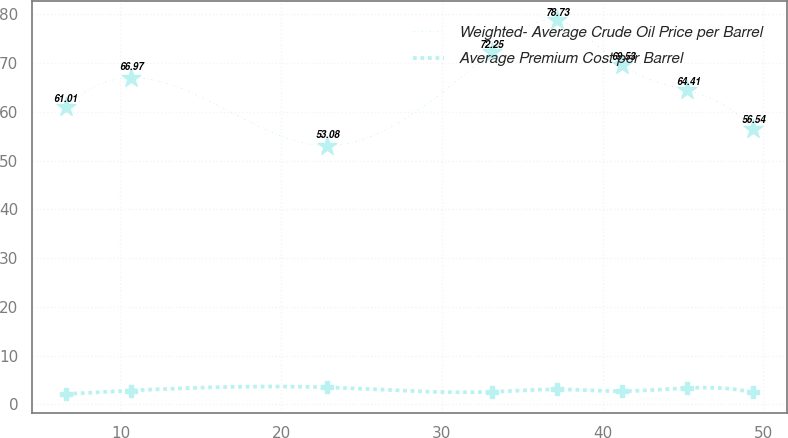Convert chart. <chart><loc_0><loc_0><loc_500><loc_500><line_chart><ecel><fcel>Weighted- Average Crude Oil Price per Barrel<fcel>Average Premium Cost per Barrel<nl><fcel>6.6<fcel>61.01<fcel>2.14<nl><fcel>10.66<fcel>66.97<fcel>2.86<nl><fcel>22.85<fcel>53.08<fcel>3.51<nl><fcel>33.09<fcel>72.25<fcel>2.59<nl><fcel>37.15<fcel>78.73<fcel>3.1<nl><fcel>41.21<fcel>69.53<fcel>2.73<nl><fcel>45.27<fcel>64.41<fcel>3.38<nl><fcel>49.33<fcel>56.54<fcel>2.46<nl></chart> 